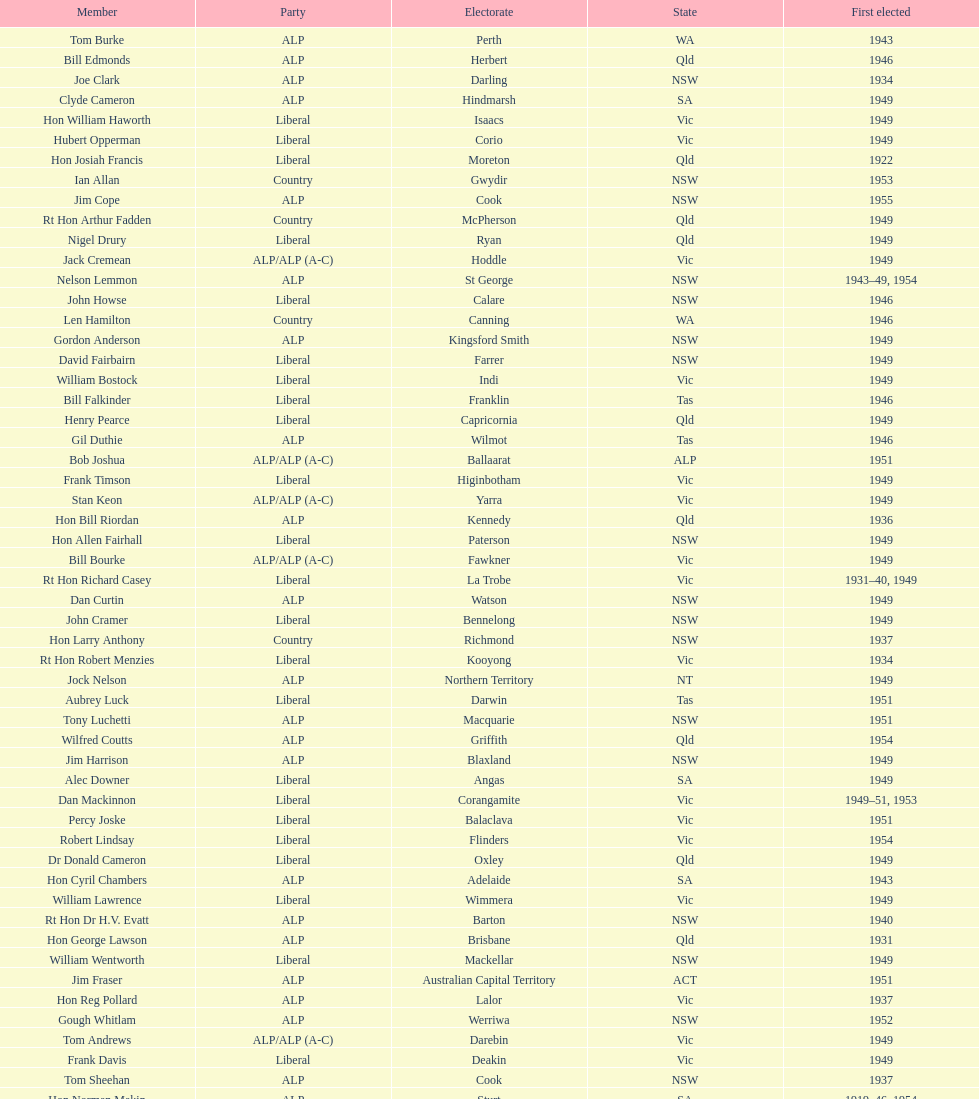When was joe clark first elected? 1934. 